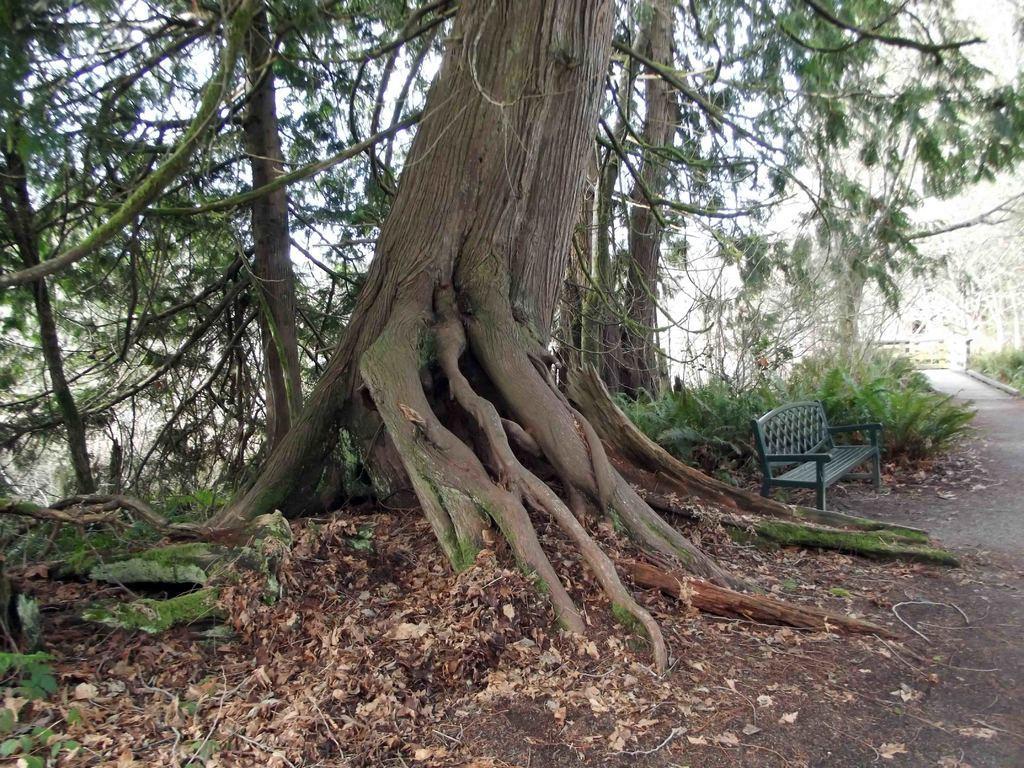In one or two sentences, can you explain what this image depicts? In the image in the center there is a fence, bench, road, trees, plants, grass and dry leaves. 